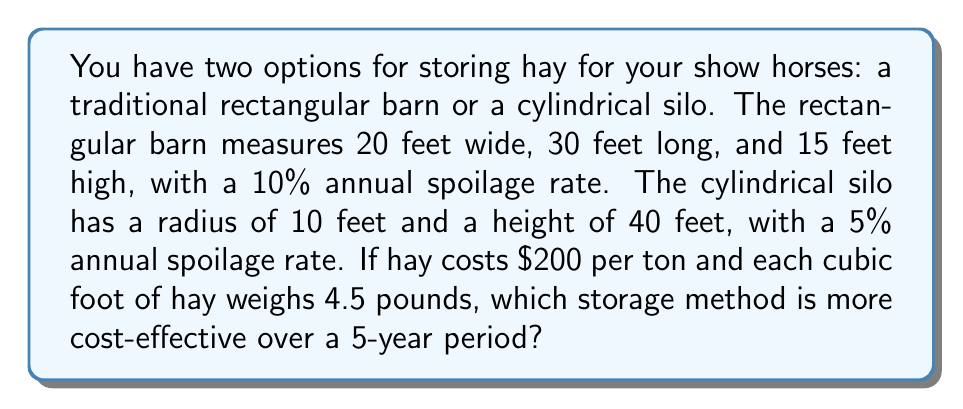Show me your answer to this math problem. 1. Calculate the volume of each storage method:
   Rectangular barn: $V_b = 20 \times 30 \times 15 = 9000$ cubic feet
   Cylindrical silo: $V_s = \pi r^2 h = \pi \times 10^2 \times 40 = 12566.37$ cubic feet

2. Calculate the weight of hay each can store:
   Barn: $W_b = 9000 \times 4.5 = 40500$ pounds $= 20.25$ tons
   Silo: $W_s = 12566.37 \times 4.5 = 56548.67$ pounds $= 28.27$ tons

3. Calculate the initial cost of hay for each:
   Barn: $C_b = 20.25 \times \$200 = \$4050$
   Silo: $C_s = 28.27 \times \$200 = \$5654$

4. Calculate the amount of hay remaining after 5 years, considering annual spoilage:
   Barn: $R_b = 20.25 \times (1 - 0.10)^5 = 12.18$ tons
   Silo: $R_s = 28.27 \times (1 - 0.05)^5 = 22.13$ tons

5. Calculate the value of remaining hay after 5 years:
   Barn: $V_b = 12.18 \times \$200 = \$2436$
   Silo: $V_s = 22.13 \times \$200 = \$4426$

6. Calculate the total cost over 5 years (initial cost - remaining value):
   Barn: $T_b = \$4050 - \$2436 = \$1614$
   Silo: $T_s = \$5654 - \$4426 = \$1228$

The cylindrical silo is more cost-effective over a 5-year period, saving $\$1614 - \$1228 = \$386$ compared to the rectangular barn.
Answer: Cylindrical silo 